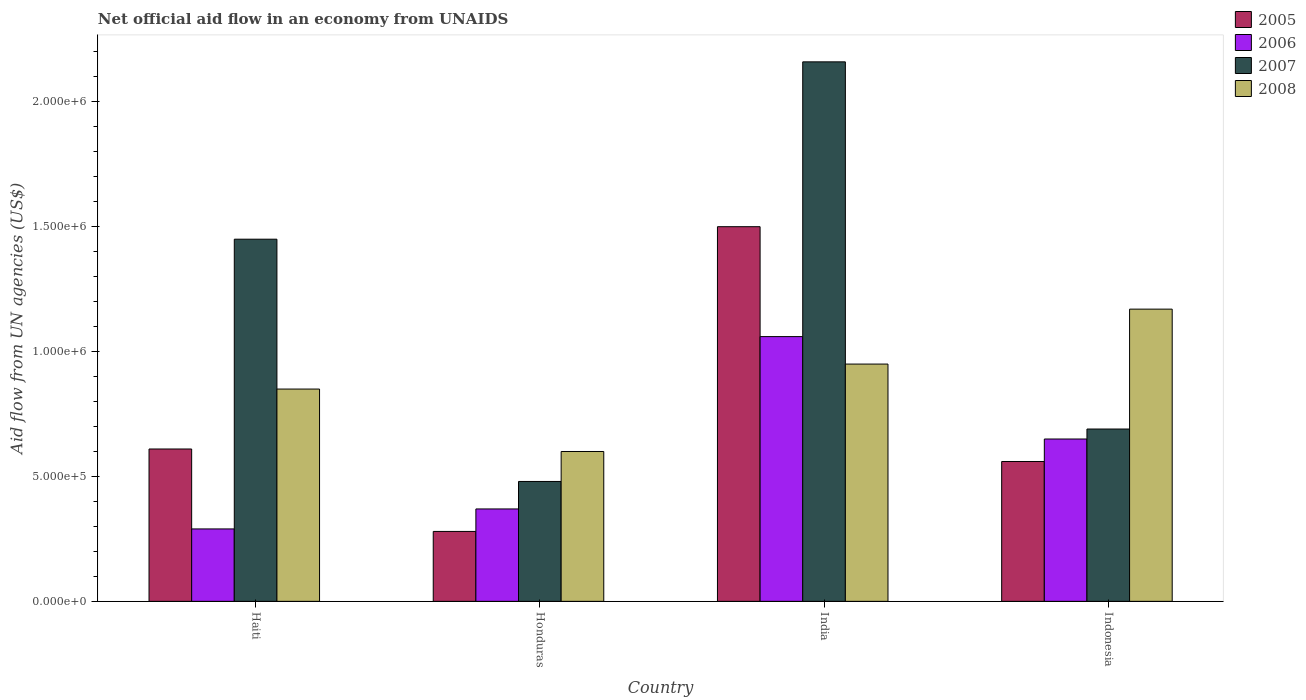How many groups of bars are there?
Provide a succinct answer. 4. Are the number of bars per tick equal to the number of legend labels?
Make the answer very short. Yes. Are the number of bars on each tick of the X-axis equal?
Make the answer very short. Yes. How many bars are there on the 3rd tick from the right?
Offer a terse response. 4. What is the label of the 2nd group of bars from the left?
Ensure brevity in your answer.  Honduras. What is the net official aid flow in 2008 in India?
Your response must be concise. 9.50e+05. Across all countries, what is the maximum net official aid flow in 2007?
Make the answer very short. 2.16e+06. Across all countries, what is the minimum net official aid flow in 2005?
Provide a succinct answer. 2.80e+05. In which country was the net official aid flow in 2006 maximum?
Offer a very short reply. India. In which country was the net official aid flow in 2008 minimum?
Ensure brevity in your answer.  Honduras. What is the total net official aid flow in 2007 in the graph?
Your response must be concise. 4.78e+06. What is the difference between the net official aid flow in 2007 in Haiti and that in India?
Ensure brevity in your answer.  -7.10e+05. What is the difference between the net official aid flow in 2007 in Haiti and the net official aid flow in 2006 in Honduras?
Keep it short and to the point. 1.08e+06. What is the average net official aid flow in 2006 per country?
Offer a very short reply. 5.92e+05. What is the ratio of the net official aid flow in 2008 in Haiti to that in Honduras?
Your answer should be very brief. 1.42. Is the difference between the net official aid flow in 2006 in Haiti and Honduras greater than the difference between the net official aid flow in 2005 in Haiti and Honduras?
Provide a succinct answer. No. What is the difference between the highest and the second highest net official aid flow in 2006?
Keep it short and to the point. 4.10e+05. What is the difference between the highest and the lowest net official aid flow in 2007?
Provide a short and direct response. 1.68e+06. In how many countries, is the net official aid flow in 2005 greater than the average net official aid flow in 2005 taken over all countries?
Make the answer very short. 1. What does the 4th bar from the right in Honduras represents?
Your answer should be compact. 2005. How many countries are there in the graph?
Offer a terse response. 4. What is the difference between two consecutive major ticks on the Y-axis?
Your response must be concise. 5.00e+05. Are the values on the major ticks of Y-axis written in scientific E-notation?
Your answer should be compact. Yes. Does the graph contain any zero values?
Your answer should be compact. No. Does the graph contain grids?
Ensure brevity in your answer.  No. Where does the legend appear in the graph?
Keep it short and to the point. Top right. How are the legend labels stacked?
Provide a succinct answer. Vertical. What is the title of the graph?
Provide a short and direct response. Net official aid flow in an economy from UNAIDS. What is the label or title of the X-axis?
Make the answer very short. Country. What is the label or title of the Y-axis?
Your answer should be very brief. Aid flow from UN agencies (US$). What is the Aid flow from UN agencies (US$) of 2005 in Haiti?
Your answer should be very brief. 6.10e+05. What is the Aid flow from UN agencies (US$) of 2007 in Haiti?
Ensure brevity in your answer.  1.45e+06. What is the Aid flow from UN agencies (US$) of 2008 in Haiti?
Give a very brief answer. 8.50e+05. What is the Aid flow from UN agencies (US$) in 2005 in India?
Make the answer very short. 1.50e+06. What is the Aid flow from UN agencies (US$) of 2006 in India?
Make the answer very short. 1.06e+06. What is the Aid flow from UN agencies (US$) of 2007 in India?
Offer a terse response. 2.16e+06. What is the Aid flow from UN agencies (US$) of 2008 in India?
Your answer should be very brief. 9.50e+05. What is the Aid flow from UN agencies (US$) in 2005 in Indonesia?
Provide a succinct answer. 5.60e+05. What is the Aid flow from UN agencies (US$) in 2006 in Indonesia?
Keep it short and to the point. 6.50e+05. What is the Aid flow from UN agencies (US$) in 2007 in Indonesia?
Provide a short and direct response. 6.90e+05. What is the Aid flow from UN agencies (US$) in 2008 in Indonesia?
Give a very brief answer. 1.17e+06. Across all countries, what is the maximum Aid flow from UN agencies (US$) of 2005?
Ensure brevity in your answer.  1.50e+06. Across all countries, what is the maximum Aid flow from UN agencies (US$) in 2006?
Offer a very short reply. 1.06e+06. Across all countries, what is the maximum Aid flow from UN agencies (US$) in 2007?
Keep it short and to the point. 2.16e+06. Across all countries, what is the maximum Aid flow from UN agencies (US$) of 2008?
Provide a succinct answer. 1.17e+06. Across all countries, what is the minimum Aid flow from UN agencies (US$) in 2008?
Your answer should be very brief. 6.00e+05. What is the total Aid flow from UN agencies (US$) in 2005 in the graph?
Offer a very short reply. 2.95e+06. What is the total Aid flow from UN agencies (US$) in 2006 in the graph?
Your answer should be very brief. 2.37e+06. What is the total Aid flow from UN agencies (US$) in 2007 in the graph?
Keep it short and to the point. 4.78e+06. What is the total Aid flow from UN agencies (US$) of 2008 in the graph?
Your answer should be very brief. 3.57e+06. What is the difference between the Aid flow from UN agencies (US$) in 2007 in Haiti and that in Honduras?
Offer a terse response. 9.70e+05. What is the difference between the Aid flow from UN agencies (US$) in 2005 in Haiti and that in India?
Your answer should be compact. -8.90e+05. What is the difference between the Aid flow from UN agencies (US$) in 2006 in Haiti and that in India?
Give a very brief answer. -7.70e+05. What is the difference between the Aid flow from UN agencies (US$) in 2007 in Haiti and that in India?
Your answer should be very brief. -7.10e+05. What is the difference between the Aid flow from UN agencies (US$) in 2008 in Haiti and that in India?
Your answer should be very brief. -1.00e+05. What is the difference between the Aid flow from UN agencies (US$) in 2005 in Haiti and that in Indonesia?
Offer a terse response. 5.00e+04. What is the difference between the Aid flow from UN agencies (US$) of 2006 in Haiti and that in Indonesia?
Keep it short and to the point. -3.60e+05. What is the difference between the Aid flow from UN agencies (US$) of 2007 in Haiti and that in Indonesia?
Offer a very short reply. 7.60e+05. What is the difference between the Aid flow from UN agencies (US$) in 2008 in Haiti and that in Indonesia?
Provide a short and direct response. -3.20e+05. What is the difference between the Aid flow from UN agencies (US$) in 2005 in Honduras and that in India?
Keep it short and to the point. -1.22e+06. What is the difference between the Aid flow from UN agencies (US$) of 2006 in Honduras and that in India?
Give a very brief answer. -6.90e+05. What is the difference between the Aid flow from UN agencies (US$) in 2007 in Honduras and that in India?
Ensure brevity in your answer.  -1.68e+06. What is the difference between the Aid flow from UN agencies (US$) in 2008 in Honduras and that in India?
Your answer should be very brief. -3.50e+05. What is the difference between the Aid flow from UN agencies (US$) of 2005 in Honduras and that in Indonesia?
Offer a terse response. -2.80e+05. What is the difference between the Aid flow from UN agencies (US$) in 2006 in Honduras and that in Indonesia?
Your response must be concise. -2.80e+05. What is the difference between the Aid flow from UN agencies (US$) in 2007 in Honduras and that in Indonesia?
Provide a succinct answer. -2.10e+05. What is the difference between the Aid flow from UN agencies (US$) in 2008 in Honduras and that in Indonesia?
Your answer should be very brief. -5.70e+05. What is the difference between the Aid flow from UN agencies (US$) in 2005 in India and that in Indonesia?
Your answer should be very brief. 9.40e+05. What is the difference between the Aid flow from UN agencies (US$) in 2007 in India and that in Indonesia?
Your response must be concise. 1.47e+06. What is the difference between the Aid flow from UN agencies (US$) in 2005 in Haiti and the Aid flow from UN agencies (US$) in 2007 in Honduras?
Your answer should be very brief. 1.30e+05. What is the difference between the Aid flow from UN agencies (US$) of 2006 in Haiti and the Aid flow from UN agencies (US$) of 2007 in Honduras?
Keep it short and to the point. -1.90e+05. What is the difference between the Aid flow from UN agencies (US$) in 2006 in Haiti and the Aid flow from UN agencies (US$) in 2008 in Honduras?
Provide a short and direct response. -3.10e+05. What is the difference between the Aid flow from UN agencies (US$) of 2007 in Haiti and the Aid flow from UN agencies (US$) of 2008 in Honduras?
Offer a very short reply. 8.50e+05. What is the difference between the Aid flow from UN agencies (US$) in 2005 in Haiti and the Aid flow from UN agencies (US$) in 2006 in India?
Give a very brief answer. -4.50e+05. What is the difference between the Aid flow from UN agencies (US$) of 2005 in Haiti and the Aid flow from UN agencies (US$) of 2007 in India?
Keep it short and to the point. -1.55e+06. What is the difference between the Aid flow from UN agencies (US$) of 2006 in Haiti and the Aid flow from UN agencies (US$) of 2007 in India?
Offer a very short reply. -1.87e+06. What is the difference between the Aid flow from UN agencies (US$) of 2006 in Haiti and the Aid flow from UN agencies (US$) of 2008 in India?
Offer a terse response. -6.60e+05. What is the difference between the Aid flow from UN agencies (US$) in 2005 in Haiti and the Aid flow from UN agencies (US$) in 2006 in Indonesia?
Make the answer very short. -4.00e+04. What is the difference between the Aid flow from UN agencies (US$) of 2005 in Haiti and the Aid flow from UN agencies (US$) of 2008 in Indonesia?
Give a very brief answer. -5.60e+05. What is the difference between the Aid flow from UN agencies (US$) of 2006 in Haiti and the Aid flow from UN agencies (US$) of 2007 in Indonesia?
Provide a short and direct response. -4.00e+05. What is the difference between the Aid flow from UN agencies (US$) in 2006 in Haiti and the Aid flow from UN agencies (US$) in 2008 in Indonesia?
Provide a succinct answer. -8.80e+05. What is the difference between the Aid flow from UN agencies (US$) of 2005 in Honduras and the Aid flow from UN agencies (US$) of 2006 in India?
Offer a very short reply. -7.80e+05. What is the difference between the Aid flow from UN agencies (US$) in 2005 in Honduras and the Aid flow from UN agencies (US$) in 2007 in India?
Your response must be concise. -1.88e+06. What is the difference between the Aid flow from UN agencies (US$) of 2005 in Honduras and the Aid flow from UN agencies (US$) of 2008 in India?
Make the answer very short. -6.70e+05. What is the difference between the Aid flow from UN agencies (US$) in 2006 in Honduras and the Aid flow from UN agencies (US$) in 2007 in India?
Make the answer very short. -1.79e+06. What is the difference between the Aid flow from UN agencies (US$) of 2006 in Honduras and the Aid flow from UN agencies (US$) of 2008 in India?
Provide a succinct answer. -5.80e+05. What is the difference between the Aid flow from UN agencies (US$) of 2007 in Honduras and the Aid flow from UN agencies (US$) of 2008 in India?
Ensure brevity in your answer.  -4.70e+05. What is the difference between the Aid flow from UN agencies (US$) of 2005 in Honduras and the Aid flow from UN agencies (US$) of 2006 in Indonesia?
Keep it short and to the point. -3.70e+05. What is the difference between the Aid flow from UN agencies (US$) in 2005 in Honduras and the Aid flow from UN agencies (US$) in 2007 in Indonesia?
Your response must be concise. -4.10e+05. What is the difference between the Aid flow from UN agencies (US$) in 2005 in Honduras and the Aid flow from UN agencies (US$) in 2008 in Indonesia?
Your response must be concise. -8.90e+05. What is the difference between the Aid flow from UN agencies (US$) of 2006 in Honduras and the Aid flow from UN agencies (US$) of 2007 in Indonesia?
Your answer should be compact. -3.20e+05. What is the difference between the Aid flow from UN agencies (US$) in 2006 in Honduras and the Aid flow from UN agencies (US$) in 2008 in Indonesia?
Provide a succinct answer. -8.00e+05. What is the difference between the Aid flow from UN agencies (US$) of 2007 in Honduras and the Aid flow from UN agencies (US$) of 2008 in Indonesia?
Offer a terse response. -6.90e+05. What is the difference between the Aid flow from UN agencies (US$) of 2005 in India and the Aid flow from UN agencies (US$) of 2006 in Indonesia?
Offer a terse response. 8.50e+05. What is the difference between the Aid flow from UN agencies (US$) in 2005 in India and the Aid flow from UN agencies (US$) in 2007 in Indonesia?
Ensure brevity in your answer.  8.10e+05. What is the difference between the Aid flow from UN agencies (US$) of 2007 in India and the Aid flow from UN agencies (US$) of 2008 in Indonesia?
Your response must be concise. 9.90e+05. What is the average Aid flow from UN agencies (US$) in 2005 per country?
Offer a very short reply. 7.38e+05. What is the average Aid flow from UN agencies (US$) in 2006 per country?
Provide a short and direct response. 5.92e+05. What is the average Aid flow from UN agencies (US$) in 2007 per country?
Make the answer very short. 1.20e+06. What is the average Aid flow from UN agencies (US$) of 2008 per country?
Your answer should be very brief. 8.92e+05. What is the difference between the Aid flow from UN agencies (US$) of 2005 and Aid flow from UN agencies (US$) of 2006 in Haiti?
Your response must be concise. 3.20e+05. What is the difference between the Aid flow from UN agencies (US$) of 2005 and Aid flow from UN agencies (US$) of 2007 in Haiti?
Offer a very short reply. -8.40e+05. What is the difference between the Aid flow from UN agencies (US$) in 2006 and Aid flow from UN agencies (US$) in 2007 in Haiti?
Your response must be concise. -1.16e+06. What is the difference between the Aid flow from UN agencies (US$) in 2006 and Aid flow from UN agencies (US$) in 2008 in Haiti?
Offer a very short reply. -5.60e+05. What is the difference between the Aid flow from UN agencies (US$) in 2005 and Aid flow from UN agencies (US$) in 2006 in Honduras?
Keep it short and to the point. -9.00e+04. What is the difference between the Aid flow from UN agencies (US$) of 2005 and Aid flow from UN agencies (US$) of 2007 in Honduras?
Provide a succinct answer. -2.00e+05. What is the difference between the Aid flow from UN agencies (US$) of 2005 and Aid flow from UN agencies (US$) of 2008 in Honduras?
Give a very brief answer. -3.20e+05. What is the difference between the Aid flow from UN agencies (US$) in 2006 and Aid flow from UN agencies (US$) in 2007 in Honduras?
Make the answer very short. -1.10e+05. What is the difference between the Aid flow from UN agencies (US$) in 2006 and Aid flow from UN agencies (US$) in 2008 in Honduras?
Ensure brevity in your answer.  -2.30e+05. What is the difference between the Aid flow from UN agencies (US$) in 2007 and Aid flow from UN agencies (US$) in 2008 in Honduras?
Your answer should be very brief. -1.20e+05. What is the difference between the Aid flow from UN agencies (US$) of 2005 and Aid flow from UN agencies (US$) of 2007 in India?
Ensure brevity in your answer.  -6.60e+05. What is the difference between the Aid flow from UN agencies (US$) in 2006 and Aid flow from UN agencies (US$) in 2007 in India?
Your response must be concise. -1.10e+06. What is the difference between the Aid flow from UN agencies (US$) in 2007 and Aid flow from UN agencies (US$) in 2008 in India?
Offer a very short reply. 1.21e+06. What is the difference between the Aid flow from UN agencies (US$) of 2005 and Aid flow from UN agencies (US$) of 2006 in Indonesia?
Your answer should be compact. -9.00e+04. What is the difference between the Aid flow from UN agencies (US$) of 2005 and Aid flow from UN agencies (US$) of 2008 in Indonesia?
Provide a succinct answer. -6.10e+05. What is the difference between the Aid flow from UN agencies (US$) in 2006 and Aid flow from UN agencies (US$) in 2007 in Indonesia?
Your response must be concise. -4.00e+04. What is the difference between the Aid flow from UN agencies (US$) of 2006 and Aid flow from UN agencies (US$) of 2008 in Indonesia?
Ensure brevity in your answer.  -5.20e+05. What is the difference between the Aid flow from UN agencies (US$) of 2007 and Aid flow from UN agencies (US$) of 2008 in Indonesia?
Offer a terse response. -4.80e+05. What is the ratio of the Aid flow from UN agencies (US$) of 2005 in Haiti to that in Honduras?
Make the answer very short. 2.18. What is the ratio of the Aid flow from UN agencies (US$) of 2006 in Haiti to that in Honduras?
Ensure brevity in your answer.  0.78. What is the ratio of the Aid flow from UN agencies (US$) of 2007 in Haiti to that in Honduras?
Ensure brevity in your answer.  3.02. What is the ratio of the Aid flow from UN agencies (US$) of 2008 in Haiti to that in Honduras?
Offer a terse response. 1.42. What is the ratio of the Aid flow from UN agencies (US$) of 2005 in Haiti to that in India?
Offer a very short reply. 0.41. What is the ratio of the Aid flow from UN agencies (US$) of 2006 in Haiti to that in India?
Your answer should be very brief. 0.27. What is the ratio of the Aid flow from UN agencies (US$) of 2007 in Haiti to that in India?
Your answer should be very brief. 0.67. What is the ratio of the Aid flow from UN agencies (US$) of 2008 in Haiti to that in India?
Ensure brevity in your answer.  0.89. What is the ratio of the Aid flow from UN agencies (US$) in 2005 in Haiti to that in Indonesia?
Offer a terse response. 1.09. What is the ratio of the Aid flow from UN agencies (US$) of 2006 in Haiti to that in Indonesia?
Make the answer very short. 0.45. What is the ratio of the Aid flow from UN agencies (US$) in 2007 in Haiti to that in Indonesia?
Your answer should be compact. 2.1. What is the ratio of the Aid flow from UN agencies (US$) in 2008 in Haiti to that in Indonesia?
Ensure brevity in your answer.  0.73. What is the ratio of the Aid flow from UN agencies (US$) of 2005 in Honduras to that in India?
Ensure brevity in your answer.  0.19. What is the ratio of the Aid flow from UN agencies (US$) of 2006 in Honduras to that in India?
Your response must be concise. 0.35. What is the ratio of the Aid flow from UN agencies (US$) of 2007 in Honduras to that in India?
Your response must be concise. 0.22. What is the ratio of the Aid flow from UN agencies (US$) in 2008 in Honduras to that in India?
Your response must be concise. 0.63. What is the ratio of the Aid flow from UN agencies (US$) of 2006 in Honduras to that in Indonesia?
Give a very brief answer. 0.57. What is the ratio of the Aid flow from UN agencies (US$) of 2007 in Honduras to that in Indonesia?
Your answer should be very brief. 0.7. What is the ratio of the Aid flow from UN agencies (US$) of 2008 in Honduras to that in Indonesia?
Offer a very short reply. 0.51. What is the ratio of the Aid flow from UN agencies (US$) of 2005 in India to that in Indonesia?
Provide a succinct answer. 2.68. What is the ratio of the Aid flow from UN agencies (US$) of 2006 in India to that in Indonesia?
Provide a succinct answer. 1.63. What is the ratio of the Aid flow from UN agencies (US$) of 2007 in India to that in Indonesia?
Offer a very short reply. 3.13. What is the ratio of the Aid flow from UN agencies (US$) in 2008 in India to that in Indonesia?
Ensure brevity in your answer.  0.81. What is the difference between the highest and the second highest Aid flow from UN agencies (US$) in 2005?
Your answer should be compact. 8.90e+05. What is the difference between the highest and the second highest Aid flow from UN agencies (US$) in 2006?
Ensure brevity in your answer.  4.10e+05. What is the difference between the highest and the second highest Aid flow from UN agencies (US$) of 2007?
Your answer should be compact. 7.10e+05. What is the difference between the highest and the lowest Aid flow from UN agencies (US$) in 2005?
Your answer should be very brief. 1.22e+06. What is the difference between the highest and the lowest Aid flow from UN agencies (US$) of 2006?
Give a very brief answer. 7.70e+05. What is the difference between the highest and the lowest Aid flow from UN agencies (US$) of 2007?
Provide a short and direct response. 1.68e+06. What is the difference between the highest and the lowest Aid flow from UN agencies (US$) in 2008?
Keep it short and to the point. 5.70e+05. 